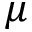<formula> <loc_0><loc_0><loc_500><loc_500>\mu</formula> 